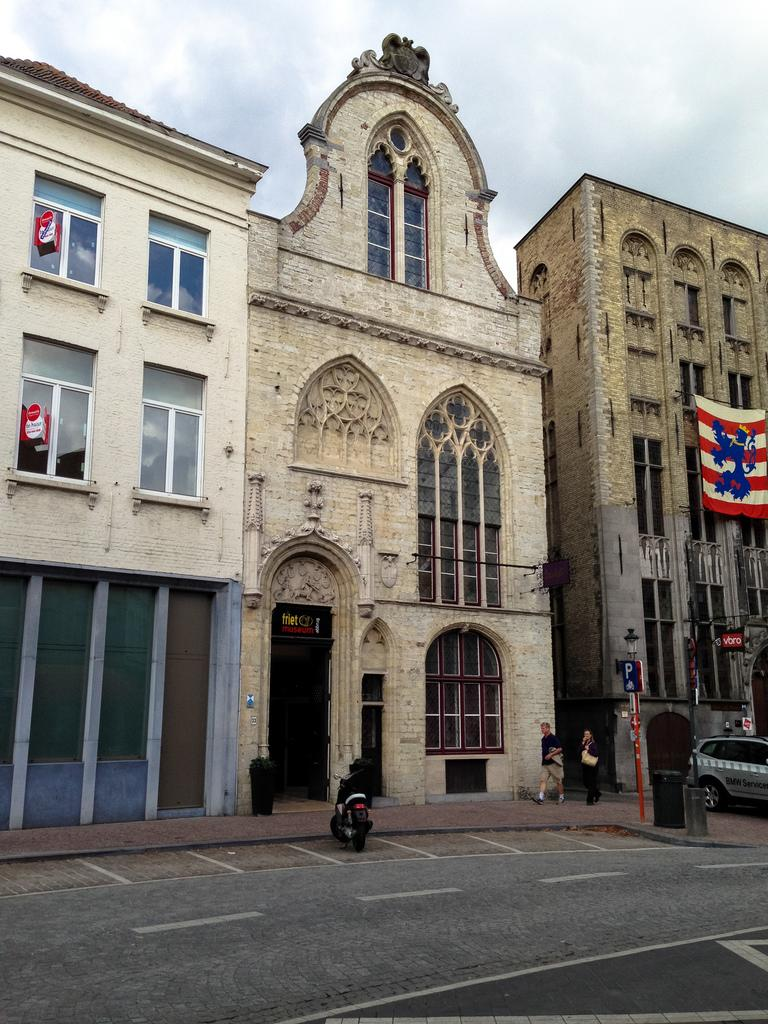What is in the foreground of the image? There is a road, vehicles, people, and poles in the foreground of the image. What can be seen in the background of the image? There are buildings, a flag, and the sky visible in the background of the image. How many types of objects are present in the foreground of the image? There are four types of objects present in the foreground: road, vehicles, people, and poles. What is the purpose of the poles in the foreground of the image? The purpose of the poles is not explicitly mentioned in the facts, but they could be for streetlights, traffic signals, or other utilities. What type of roof can be seen on the vehicles in the image? There are no roofs mentioned in the image, as it only describes the presence of vehicles in the foreground. How does the pump help the people in the image? There is no pump present in the image, so it cannot help the people in any way. 